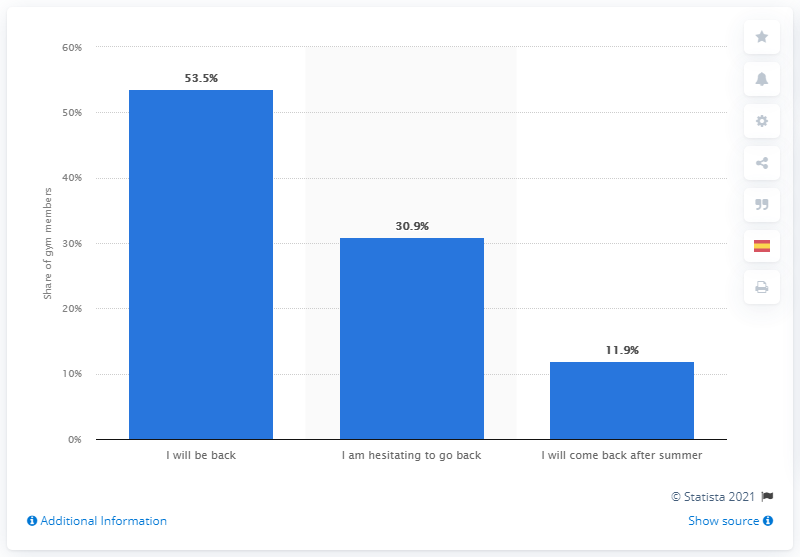Point out several critical features in this image. A significant percentage of Spaniards, 30.9%, were unsure about returning to their sports center. 